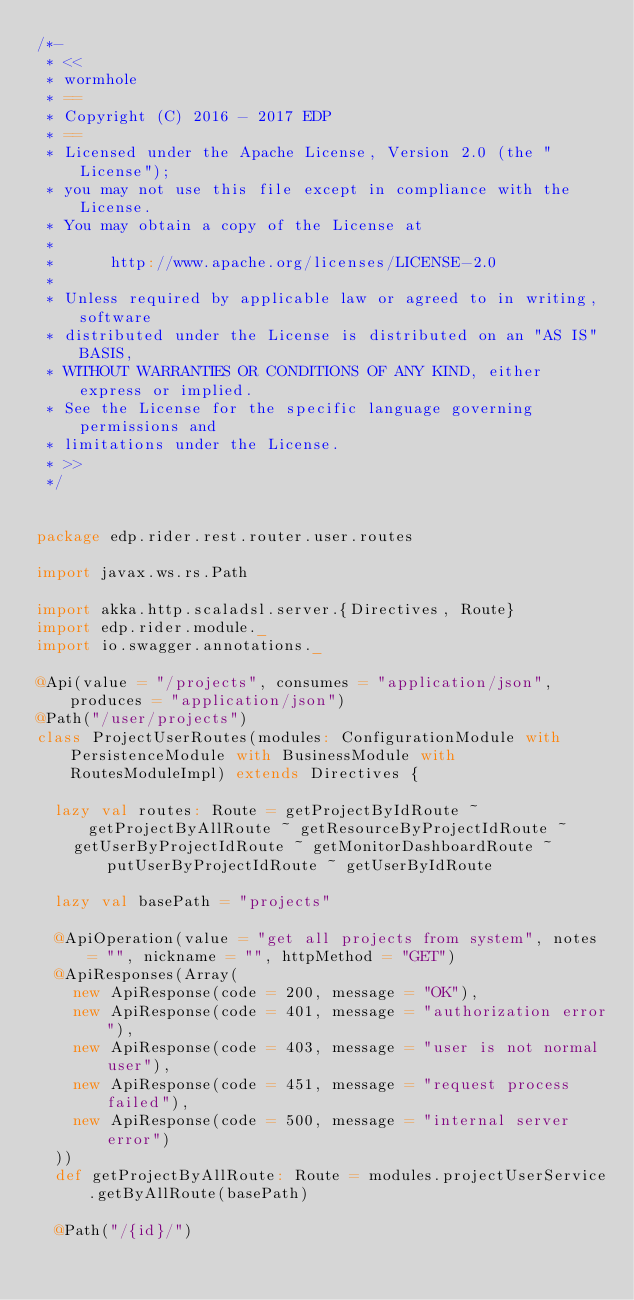<code> <loc_0><loc_0><loc_500><loc_500><_Scala_>/*-
 * <<
 * wormhole
 * ==
 * Copyright (C) 2016 - 2017 EDP
 * ==
 * Licensed under the Apache License, Version 2.0 (the "License");
 * you may not use this file except in compliance with the License.
 * You may obtain a copy of the License at
 * 
 *      http://www.apache.org/licenses/LICENSE-2.0
 * 
 * Unless required by applicable law or agreed to in writing, software
 * distributed under the License is distributed on an "AS IS" BASIS,
 * WITHOUT WARRANTIES OR CONDITIONS OF ANY KIND, either express or implied.
 * See the License for the specific language governing permissions and
 * limitations under the License.
 * >>
 */


package edp.rider.rest.router.user.routes

import javax.ws.rs.Path

import akka.http.scaladsl.server.{Directives, Route}
import edp.rider.module._
import io.swagger.annotations._

@Api(value = "/projects", consumes = "application/json", produces = "application/json")
@Path("/user/projects")
class ProjectUserRoutes(modules: ConfigurationModule with PersistenceModule with BusinessModule with RoutesModuleImpl) extends Directives {

  lazy val routes: Route = getProjectByIdRoute ~ getProjectByAllRoute ~ getResourceByProjectIdRoute ~
    getUserByProjectIdRoute ~ getMonitorDashboardRoute ~ putUserByProjectIdRoute ~ getUserByIdRoute

  lazy val basePath = "projects"

  @ApiOperation(value = "get all projects from system", notes = "", nickname = "", httpMethod = "GET")
  @ApiResponses(Array(
    new ApiResponse(code = 200, message = "OK"),
    new ApiResponse(code = 401, message = "authorization error"),
    new ApiResponse(code = 403, message = "user is not normal user"),
    new ApiResponse(code = 451, message = "request process failed"),
    new ApiResponse(code = 500, message = "internal server error")
  ))
  def getProjectByAllRoute: Route = modules.projectUserService.getByAllRoute(basePath)

  @Path("/{id}/")</code> 